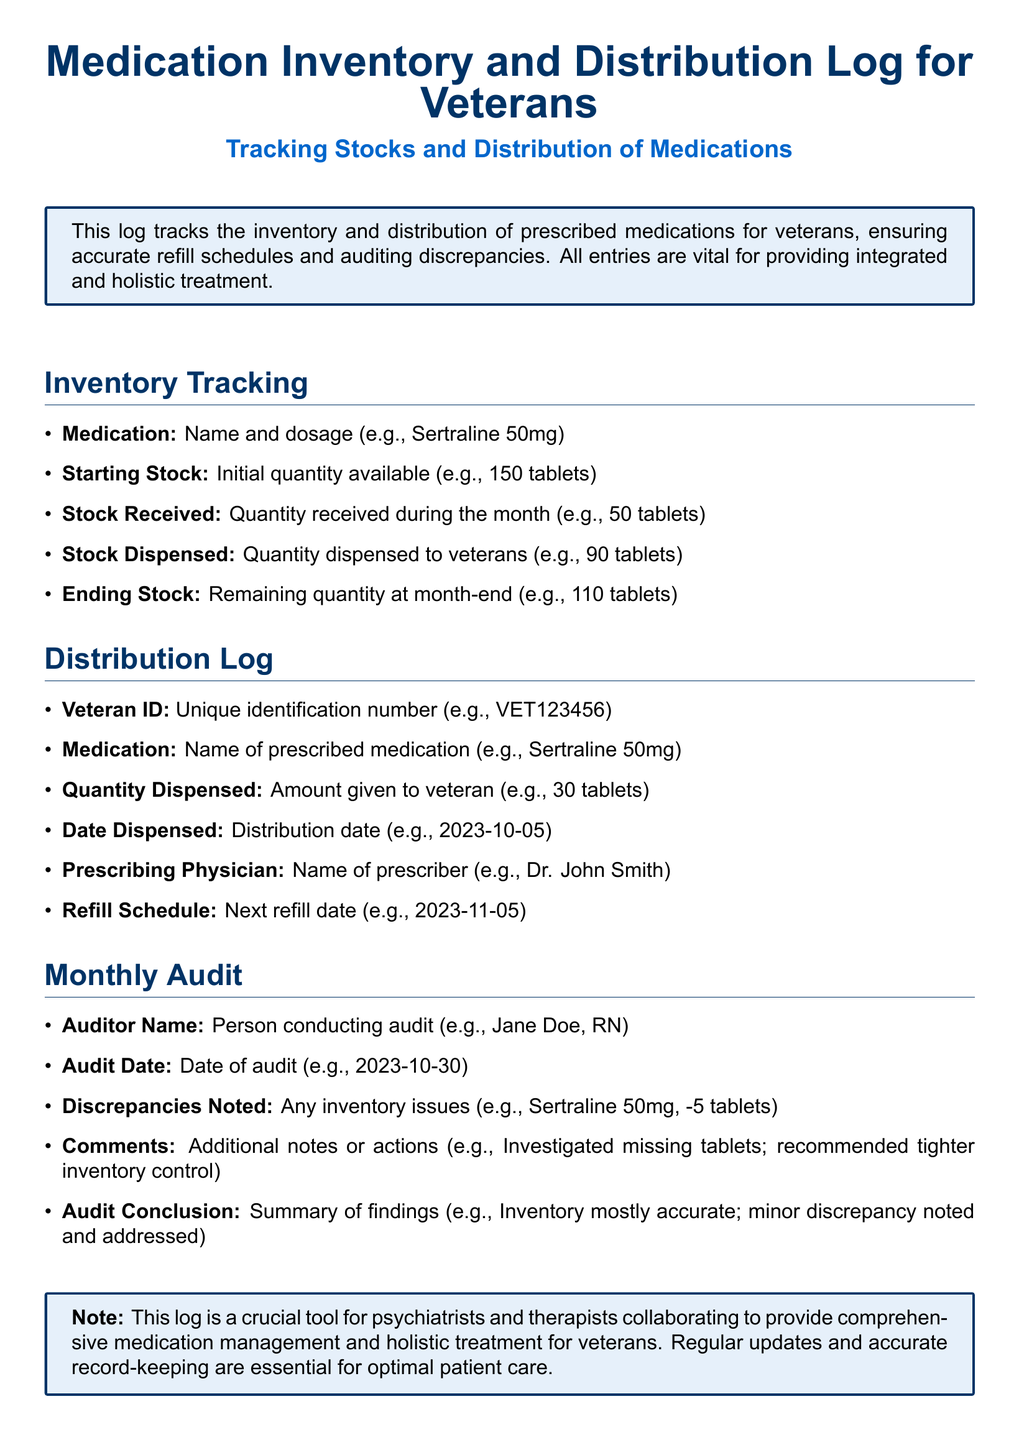what is the name of the medication with a specified dosage in the inventory tracking? The name of the medication can be found under the Inventory Tracking section, which mentions examples like Sertraline 50mg.
Answer: Sertraline 50mg what is the starting stock of the medication referred to? The starting stock is the initial quantity available, as indicated in the examples, such as 150 tablets.
Answer: 150 tablets who conducted the monthly audit? The auditor's name is noted in the Monthly Audit section, with an example provided, such as Jane Doe, RN.
Answer: Jane Doe, RN what is the next refill date for the medication prescribed? The refill schedule indicates when the next refill is due, such as 2023-11-05 in the example.
Answer: 2023-11-05 how many tablets were noted as missing in the discrepancies? Discrepancies noted in the monthly audit specify issues, for instance, -5 tablets of Sertraline.
Answer: -5 tablets what is the purpose of the medication inventory and distribution log? The log is designed for tracking the inventory and distribution of prescribed medications to ensure accurate refill schedules and auditing.
Answer: Tracking stocks and distribution of medications how is the audit conclusion summarized? The audit conclusion provides a summary of findings regarding the accuracy of inventory and any discrepancies noted. An example states that inventory is mostly accurate with minor discrepancies.
Answer: Inventory mostly accurate; minor discrepancy noted and addressed when was the last audit conducted? The audit date can be found in the Monthly Audit section, with an example of the date provided, like 2023-10-30.
Answer: 2023-10-30 